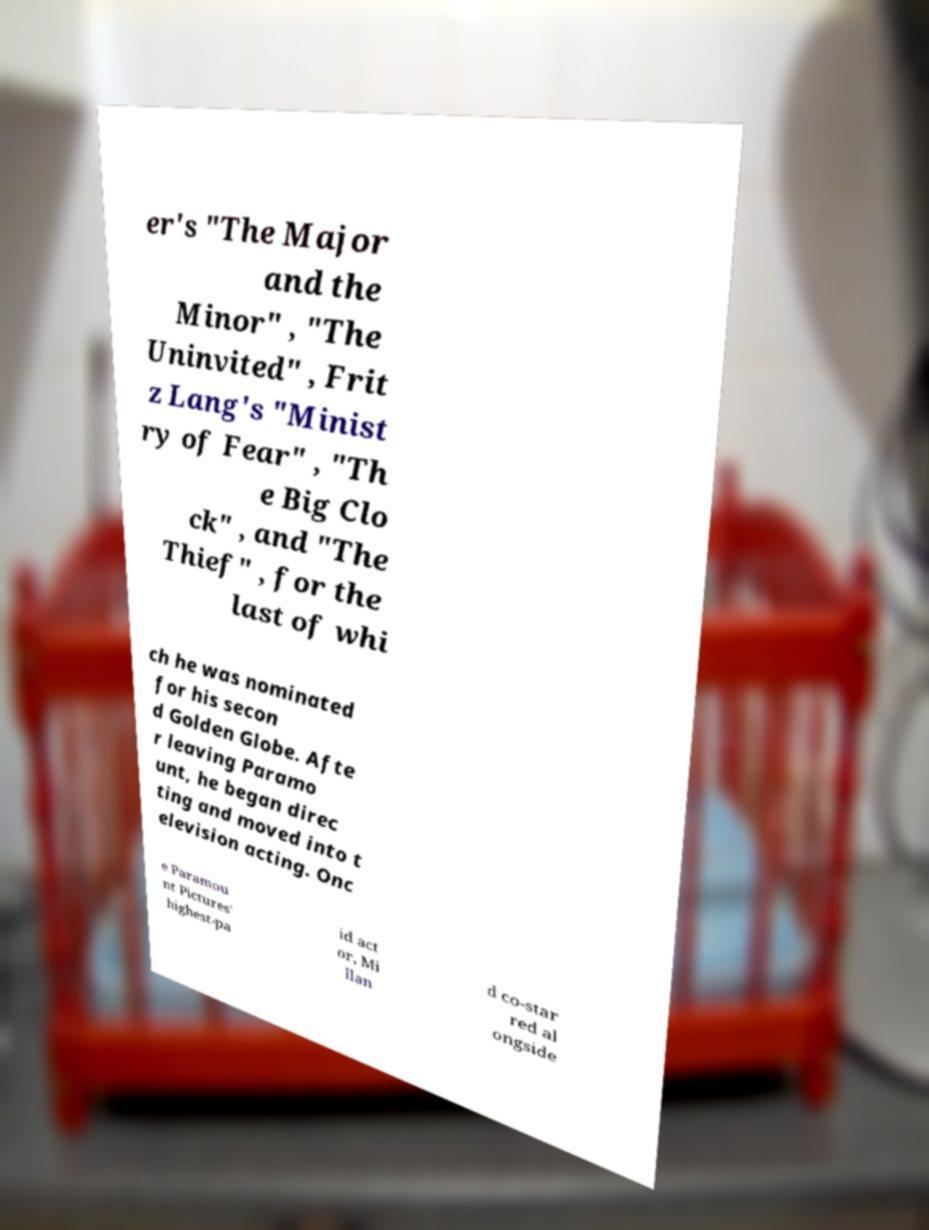Please identify and transcribe the text found in this image. er's "The Major and the Minor" , "The Uninvited" , Frit z Lang's "Minist ry of Fear" , "Th e Big Clo ck" , and "The Thief" , for the last of whi ch he was nominated for his secon d Golden Globe. Afte r leaving Paramo unt, he began direc ting and moved into t elevision acting. Onc e Paramou nt Pictures' highest-pa id act or, Mi llan d co-star red al ongside 